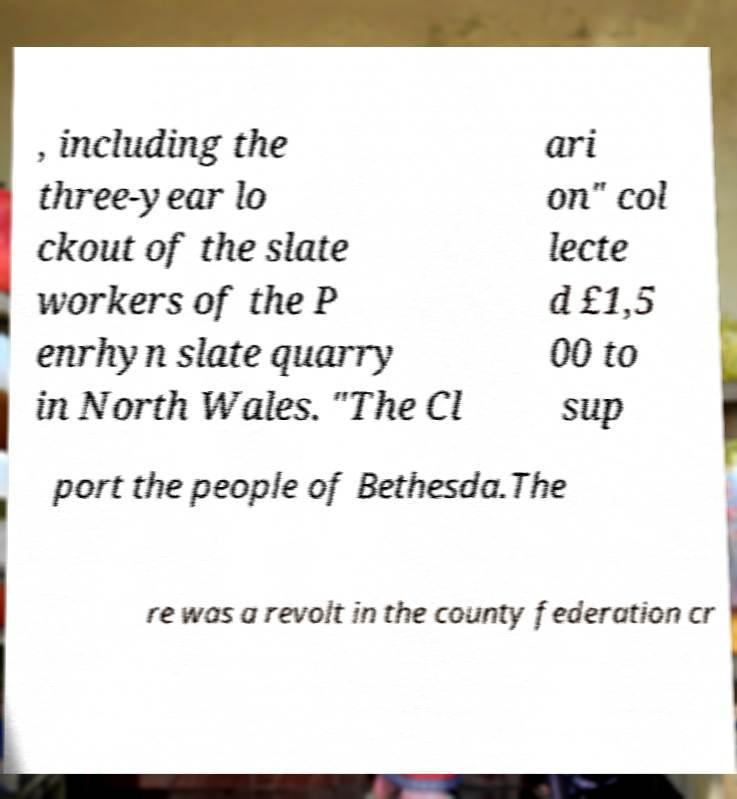Could you extract and type out the text from this image? , including the three-year lo ckout of the slate workers of the P enrhyn slate quarry in North Wales. "The Cl ari on" col lecte d £1,5 00 to sup port the people of Bethesda.The re was a revolt in the county federation cr 